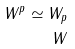Convert formula to latex. <formula><loc_0><loc_0><loc_500><loc_500>W ^ { p } \simeq W _ { p } \\ W</formula> 